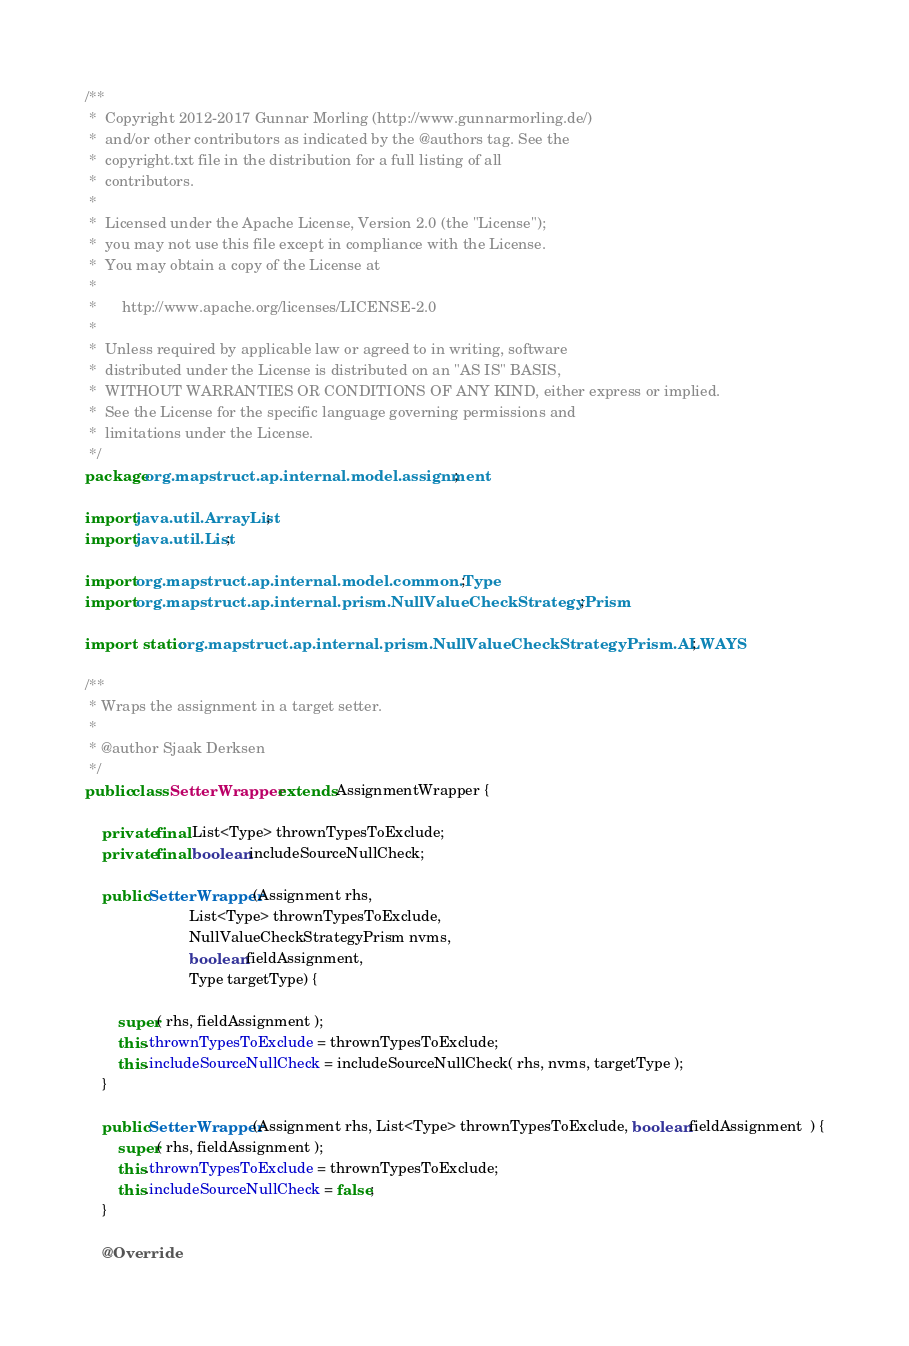<code> <loc_0><loc_0><loc_500><loc_500><_Java_>/**
 *  Copyright 2012-2017 Gunnar Morling (http://www.gunnarmorling.de/)
 *  and/or other contributors as indicated by the @authors tag. See the
 *  copyright.txt file in the distribution for a full listing of all
 *  contributors.
 *
 *  Licensed under the Apache License, Version 2.0 (the "License");
 *  you may not use this file except in compliance with the License.
 *  You may obtain a copy of the License at
 *
 *      http://www.apache.org/licenses/LICENSE-2.0
 *
 *  Unless required by applicable law or agreed to in writing, software
 *  distributed under the License is distributed on an "AS IS" BASIS,
 *  WITHOUT WARRANTIES OR CONDITIONS OF ANY KIND, either express or implied.
 *  See the License for the specific language governing permissions and
 *  limitations under the License.
 */
package org.mapstruct.ap.internal.model.assignment;

import java.util.ArrayList;
import java.util.List;

import org.mapstruct.ap.internal.model.common.Type;
import org.mapstruct.ap.internal.prism.NullValueCheckStrategyPrism;

import static org.mapstruct.ap.internal.prism.NullValueCheckStrategyPrism.ALWAYS;

/**
 * Wraps the assignment in a target setter.
 *
 * @author Sjaak Derksen
 */
public class SetterWrapper extends AssignmentWrapper {

    private final List<Type> thrownTypesToExclude;
    private final boolean includeSourceNullCheck;

    public SetterWrapper(Assignment rhs,
                         List<Type> thrownTypesToExclude,
                         NullValueCheckStrategyPrism nvms,
                         boolean fieldAssignment,
                         Type targetType) {

        super( rhs, fieldAssignment );
        this.thrownTypesToExclude = thrownTypesToExclude;
        this.includeSourceNullCheck = includeSourceNullCheck( rhs, nvms, targetType );
    }

    public SetterWrapper(Assignment rhs, List<Type> thrownTypesToExclude, boolean fieldAssignment  ) {
        super( rhs, fieldAssignment );
        this.thrownTypesToExclude = thrownTypesToExclude;
        this.includeSourceNullCheck = false;
    }

    @Override</code> 